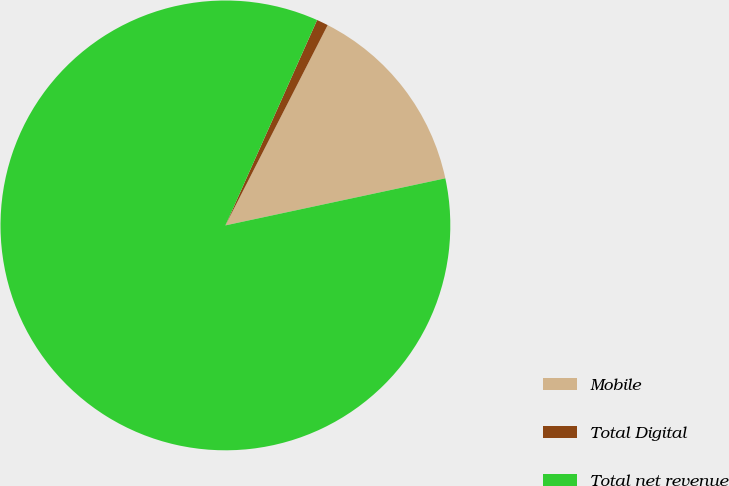Convert chart to OTSL. <chart><loc_0><loc_0><loc_500><loc_500><pie_chart><fcel>Mobile<fcel>Total Digital<fcel>Total net revenue<nl><fcel>14.13%<fcel>0.83%<fcel>85.04%<nl></chart> 